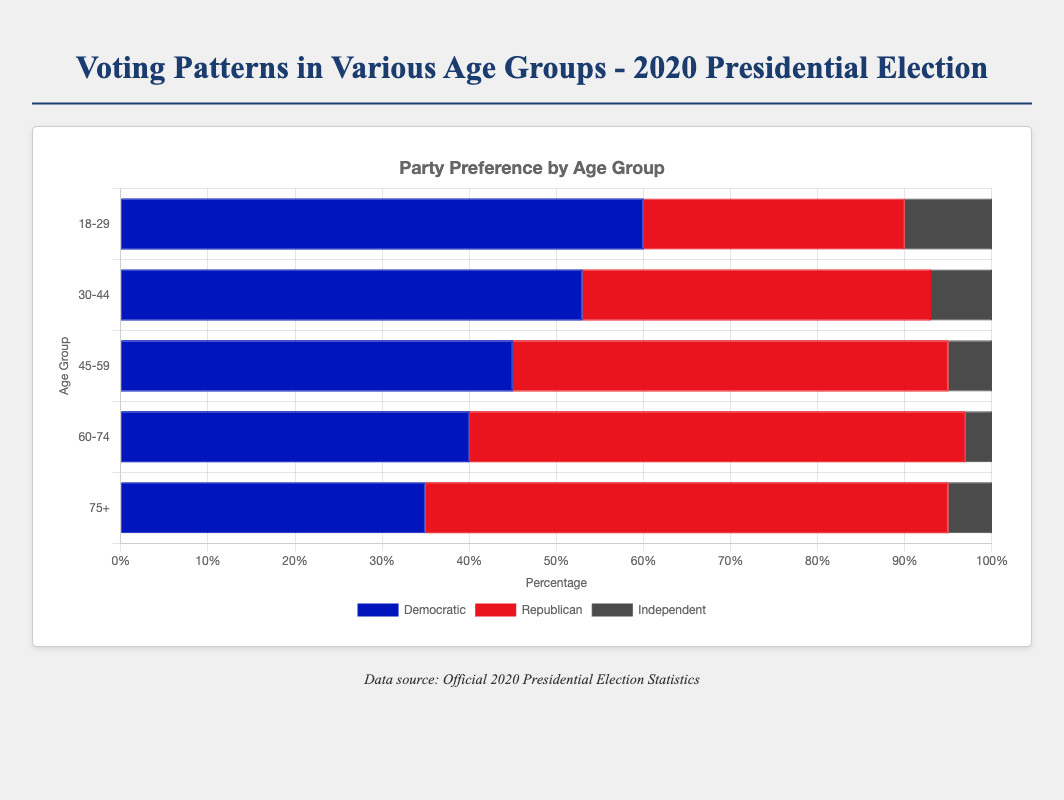What is the voter turnout percentage for the 75+ age group? The voter turnout percentage is given directly in the figure for each age group. For the 75+ age group, it shows 82%.
Answer: 82% Which age group has the highest preference for the Democratic party? The Democratic preference percentages are compared across all age groups. The 18-29 age group has the highest Democratic preference at 60%.
Answer: 18-29 Among the age groups 18-29 and 45-59, which one had a higher Republican preference? Compare the Republican preference for both age groups: 18-29 has 30% while 45-59 has 50%. The 45-59 group had a higher Republican preference.
Answer: 45-59 What is the total percentage of voters who prefer the Republican party in the age group 60-74? The Republican preference for the 60-74 age group is given directly in the figure, which is 57%.
Answer: 57% Compare the voter turnout between the age groups 30-44 and 45-59. Which age group had a higher turnout? The 30-44 age group had 60% turnout, while the 45-59 age group had 70% turnout. The 45-59 age group had a higher turnout.
Answer: 45-59 What is the average voter turnout percentage across all age groups? Add the voter turnout percentages of all age groups (50 + 60 + 70 + 78 + 82) and divide by the number of age groups (5). The average is (50 + 60 + 70 + 78 + 82) / 5 = 68%.
Answer: 68% What is the difference in percentage points between the Democratic and Republican preference in the age group 30-44? In the 30-44 age group, the Democratic preference is 53% and the Republican preference is 40%. The difference is 53% - 40% = 13%.
Answer: 13% What percentage of 18-29 year-olds are Independents? The figure shows the Independent preference directly for each age group. For the 18-29 age group, it is 10%.
Answer: 10% Which age group shows the smallest percentage of Independent voters? Comparing the percentage of Independent voters across all age groups, the 60-74 age group has the smallest at 3%.
Answer: 60-74 What is the combined percentage of Democratic and Republican preference in the 75+ age group? Add the Democratic and Republican preferences together for the 75+ age group: 35% + 60% = 95%.
Answer: 95% 